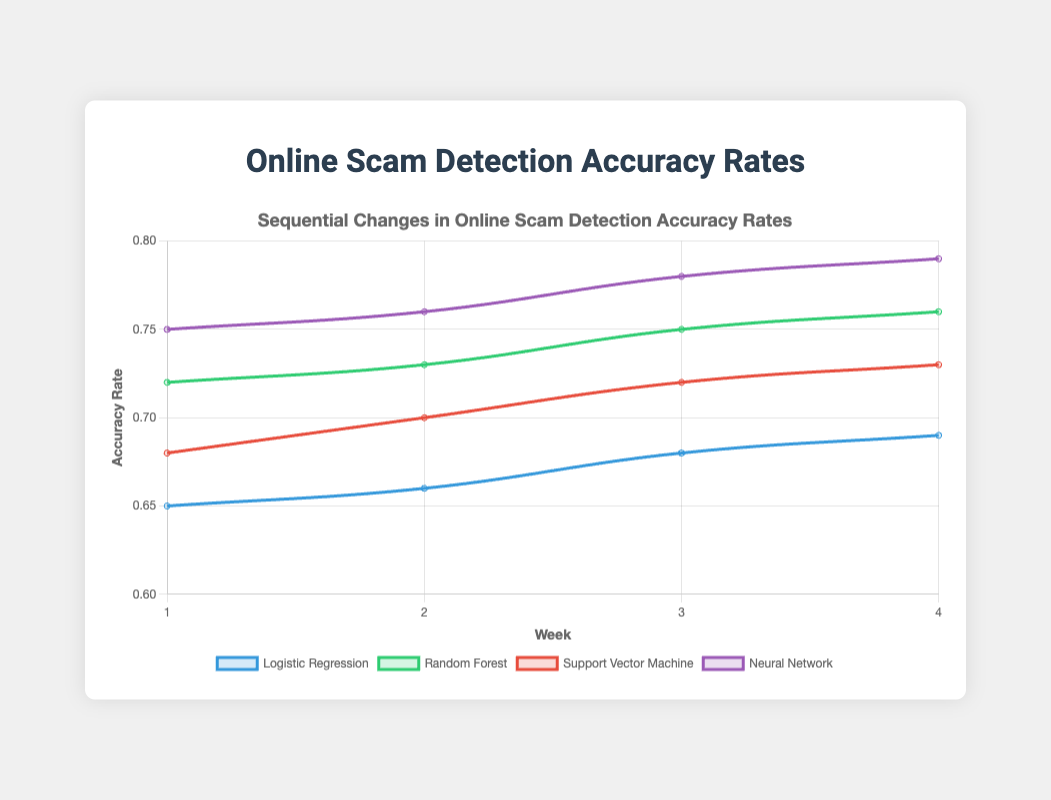What is the maximum accuracy rate achieved by the Neural Network model? Observe the Neural Network line, which is represented in purple. The highest point on this line corresponds to week 4 at an accuracy rate of 0.79.
Answer: 0.79 Which model shows the smallest increase in accuracy rate over the 4 weeks? Calculate the difference between week 4 and week 1 accuracy rates for all models: Logistic Regression (0.04), Random Forest (0.04), Support Vector Machine (0.05), Neural Network (0.04). Logistic Regression, Random Forest, and Neural Network all show increases of 0.04, the smallest increment.
Answer: Logistic Regression, Random Forest, Neural Network Between weeks 2 and 3, which model shows the largest increase in accuracy rate? Examine the differences between week 2 and week 3 accuracy rates: Logistic Regression (0.68 - 0.66 = 0.02), Random Forest (0.75 - 0.73 = 0.02), Support Vector Machine (0.72 - 0.70 = 0.02), Neural Network (0.78 - 0.76 = 0.02). All increases are the same, at 0.02.
Answer: None—all are equal at 0.02 Considering the accuracy rates of week 1, which model has the highest starting accuracy? Look at the values for week 1: Logistic Regression (0.65), Random Forest (0.72), Support Vector Machine (0.68), Neural Network (0.75). The Neural Network model has the highest starting accuracy of 0.75.
Answer: Neural Network How much higher is the week 4 accuracy rate of the Random Forest model compared to the Logistic Regression model? The week 4 accuracy rates are Logistic Regression (0.69) and Random Forest (0.76). Subtract Logistic Regression's rate from Random Forest's rate: 0.76 - 0.69 = 0.07.
Answer: 0.07 What is the average accuracy rate of the Support Vector Machine model over the 4 weeks? Add up the accuracy rates for each week for the Support Vector Machine model: 0.68 + 0.70 + 0.72 + 0.73 = 2.83. The average is 2.83 / 4 = 0.7075.
Answer: 0.7075 Which weeks show the most considerable increase for the Neural Network model? Compare the increases week-to-week for the Neural Network model: Week 2 - Week 1 (0.76 - 0.75 = 0.01), Week 3 - Week 2 (0.78 - 0.76 = 0.02), Week 4 - Week 3 (0.79 - 0.78 = 0.01). The most considerable increase occurred between week 2 and week 3, with an increase of 0.02.
Answer: Between week 2 and week 3 Which model experiences the steepest upward trend in the accuracy rate between weeks 1 and 4? Calculate the overall slope for each model by dividing the total increase by the weeks: Logistic Regression (0.69 - 0.65) / 3 = 0.0133, Random Forest (0.76 - 0.72) / 3 = 0.0133, Support Vector Machine (0.73 - 0.68) / 3 = 0.0167, Neural Network (0.79 - 0.75) / 3 = 0.0133. The Support Vector Machine model has the steepest upward trend with a slope of 0.0167.
Answer: Support Vector Machine What's the difference in accuracy rates between week 3 of the Random Forest model and week 3 of the Support Vector Machine model? Look at the week 3 accuracy rates: Random Forest (0.75) and Support Vector Machine (0.72). Subtract the latter from the former: 0.75 - 0.72 = 0.03.
Answer: 0.03 